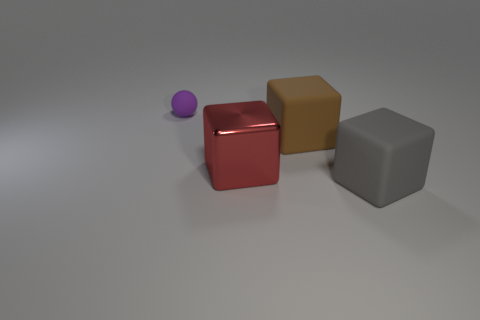Subtract all big metal cubes. How many cubes are left? 2 Subtract all brown blocks. How many blocks are left? 2 Add 4 tiny matte spheres. How many tiny matte spheres are left? 5 Add 3 brown blocks. How many brown blocks exist? 4 Add 1 yellow spheres. How many objects exist? 5 Subtract 0 cyan cylinders. How many objects are left? 4 Subtract all cubes. How many objects are left? 1 Subtract 1 blocks. How many blocks are left? 2 Subtract all blue balls. Subtract all gray cubes. How many balls are left? 1 Subtract all cyan balls. How many red cubes are left? 1 